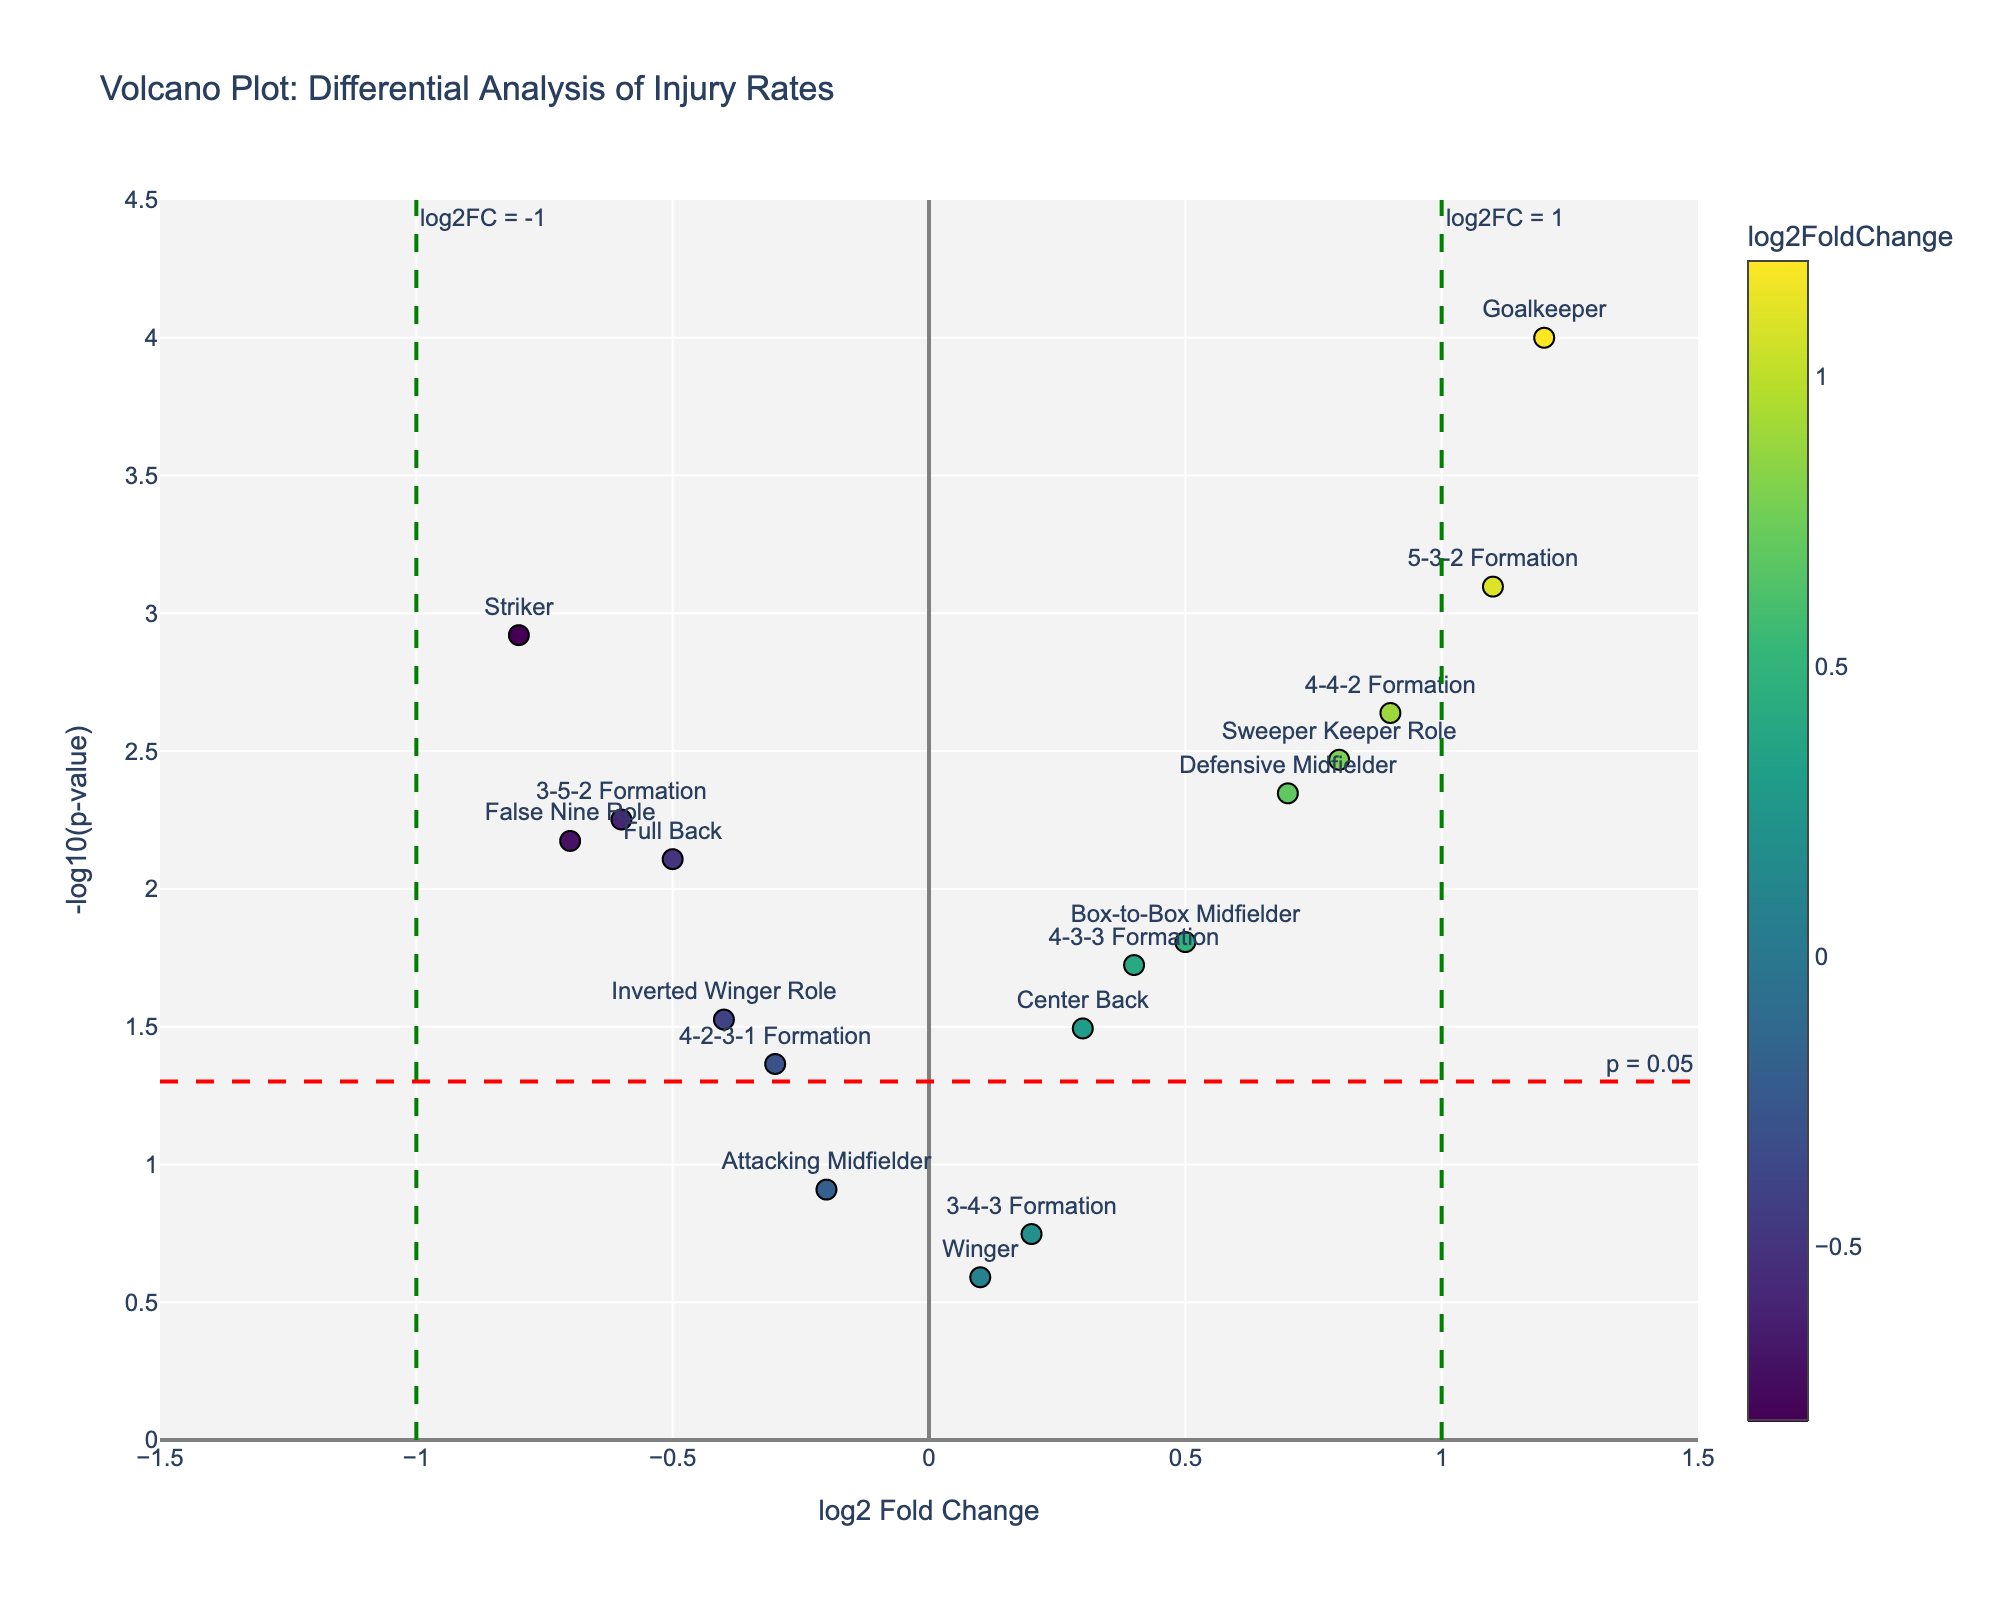What's the title of the plot? The title is located at the top of the plot and should be clearly visible.
Answer: Volcano Plot: Differential Analysis of Injury Rates What's the color of the data point with the highest log2 fold change? Look for the point that has the highest x-axis value (1.2) and observe its color.
Answer: A light yellow-green color How many positions/formations have a significant p-value (p < 0.05)? Identify the data points that are above the horizontal red dashed line at y = -log10(0.05). Count the number of these points.
Answer: 11 Which position or role has the least negative log2 fold change? Among the positions or roles with negative values on the x-axis (log2 fold change), find the one closest to zero.
Answer: Attacking Midfielder What is the p-value threshold indicated by the horizontal line? The horizontal line is labeled as "p = 0.05", which indicates the significance threshold.
Answer: 0.05 Which formation has the highest injury rate increase? Find the data point with the highest positive log2 fold change associated with a formation.
Answer: 5-3-2 Formation Compare the injury rates of the 4-4-2 and 3-5-2 formations. Which one has a higher injury rate? Look at the log2 fold change values for both formations and compare them. The one with the higher positive value has a higher injury rate.
Answer: 4-4-2 Formation Is the Striker position more or less prone to injury compared to the Goalkeeper? Compare the log2 fold change values for Striker (-0.8) and Goalkeeper (1.2). A higher positive value indicates a higher injury rate.
Answer: Less prone What is the range of -log10(p-values) displayed in the plot? Identify the minimum and maximum values for the y-axis (-log10(p-values)) displayed in the plot.
Answer: From 0 to 4.5 Among the positions investigated, which has the smallest p-value and what is it? Identify the data point corresponding to a position with the smallest y-axis value (-log10(p-value)) and check its text label to find the position and its p-value.
Answer: Goalkeeper, p = 0.0001 